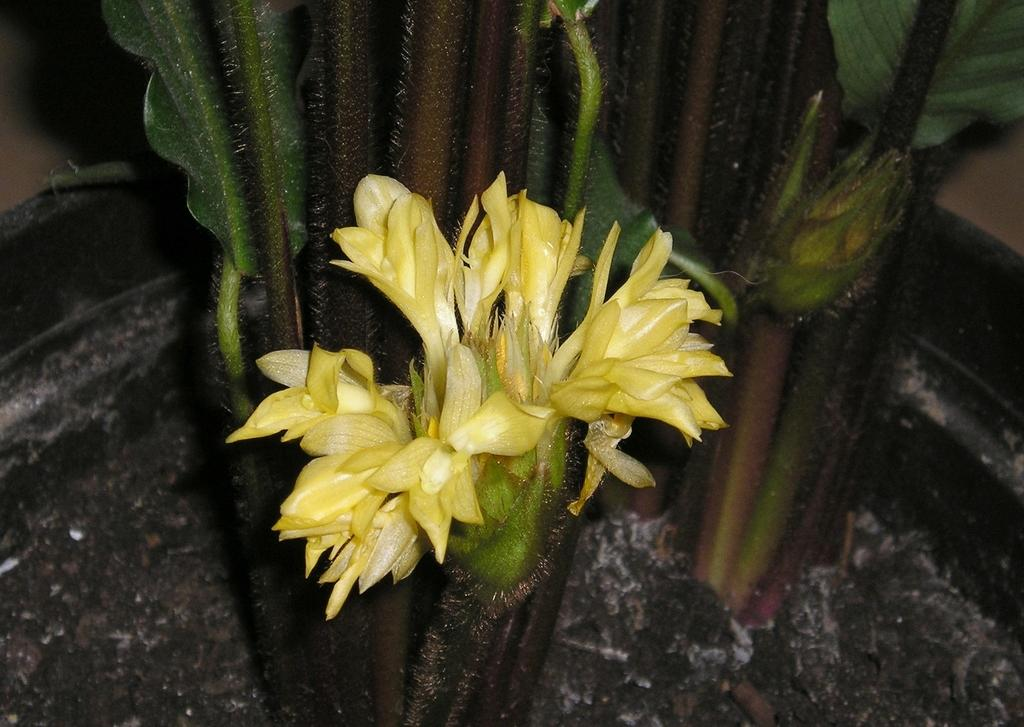What is the main subject of the image? The main subject of the image is a flower. Where is the flower located? The flower is on a plant. What color is the flower? The flower is yellow. Can you describe the background of the image? The background of the image is blurred. What type of stocking is the flower wearing in the image? There is no stocking present in the image, as flowers do not wear stockings. 